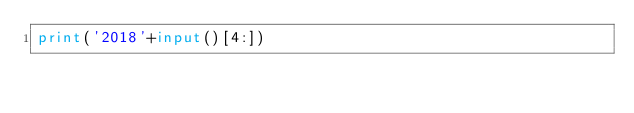<code> <loc_0><loc_0><loc_500><loc_500><_Python_>print('2018'+input()[4:])</code> 